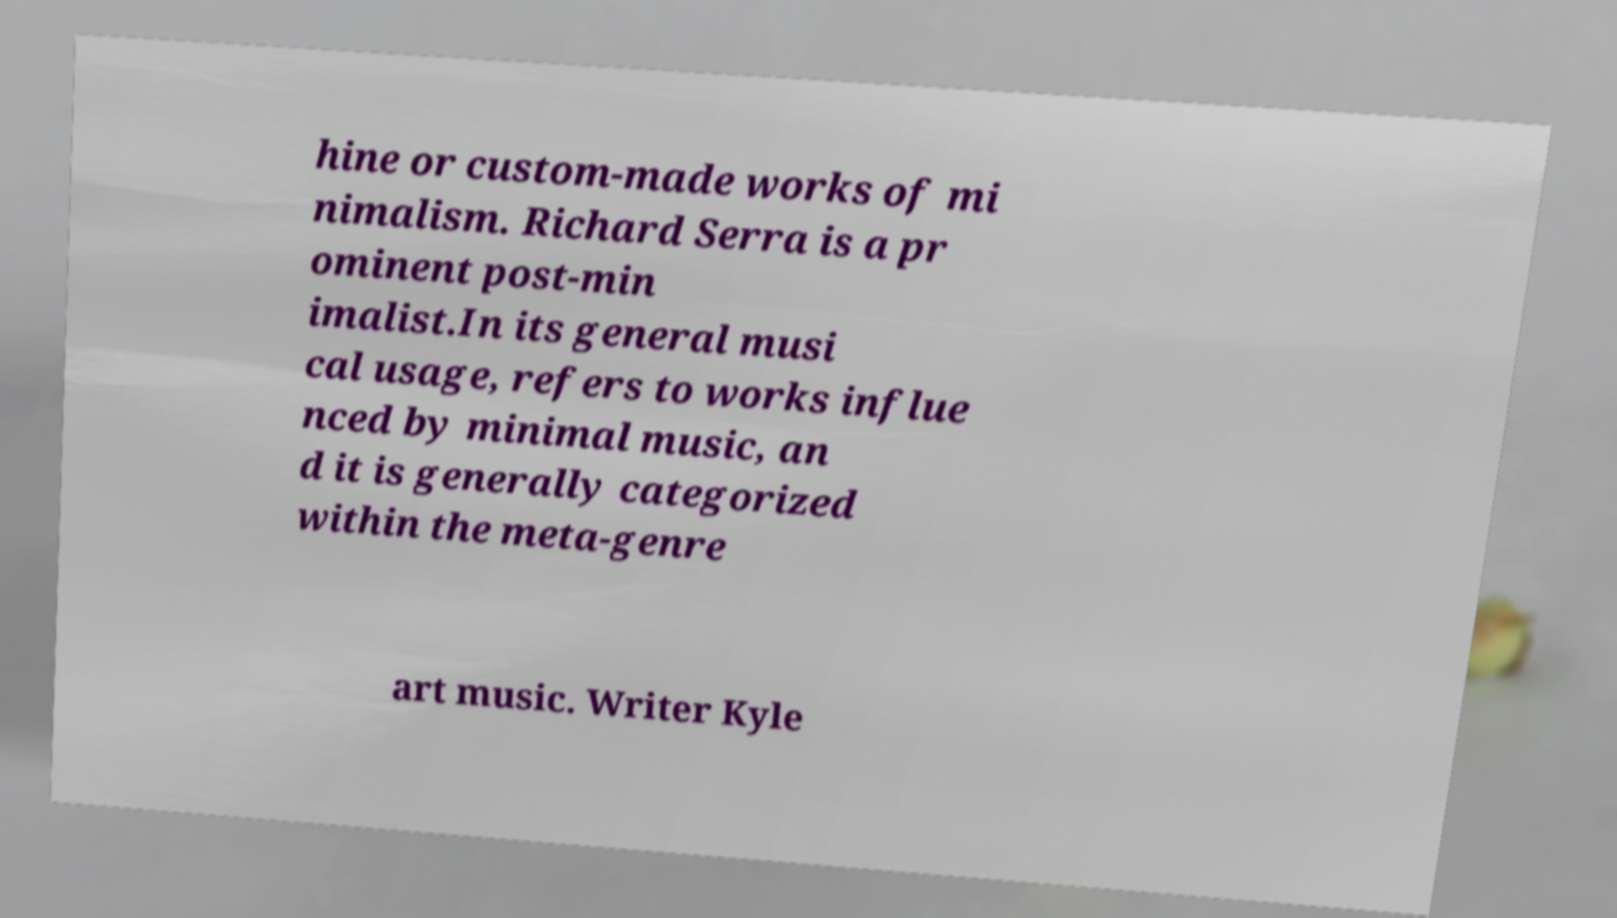Please read and relay the text visible in this image. What does it say? hine or custom-made works of mi nimalism. Richard Serra is a pr ominent post-min imalist.In its general musi cal usage, refers to works influe nced by minimal music, an d it is generally categorized within the meta-genre art music. Writer Kyle 